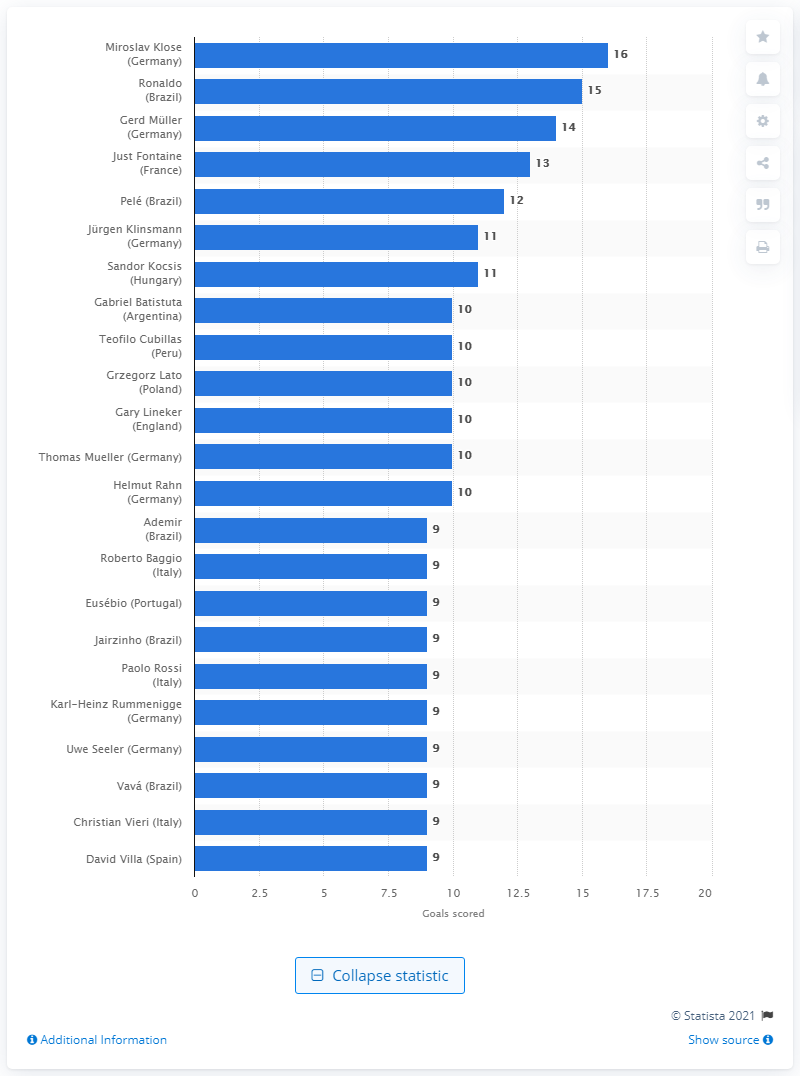Indicate a few pertinent items in this graphic. Miroslav Klose has scored 16 goals. 